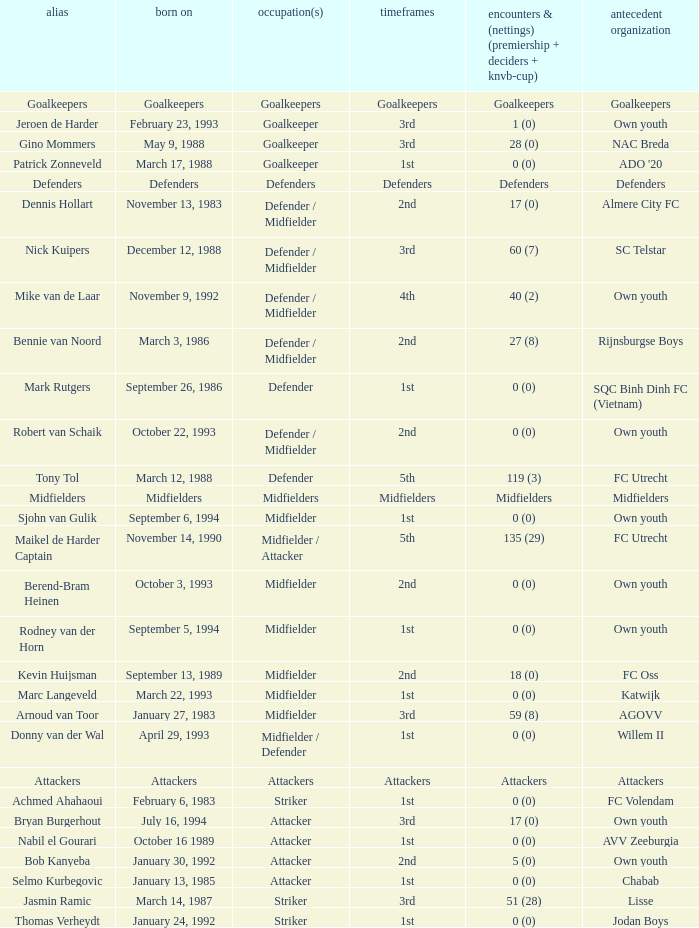What is the date of birth of the goalkeeper from the 1st season? March 17, 1988. 